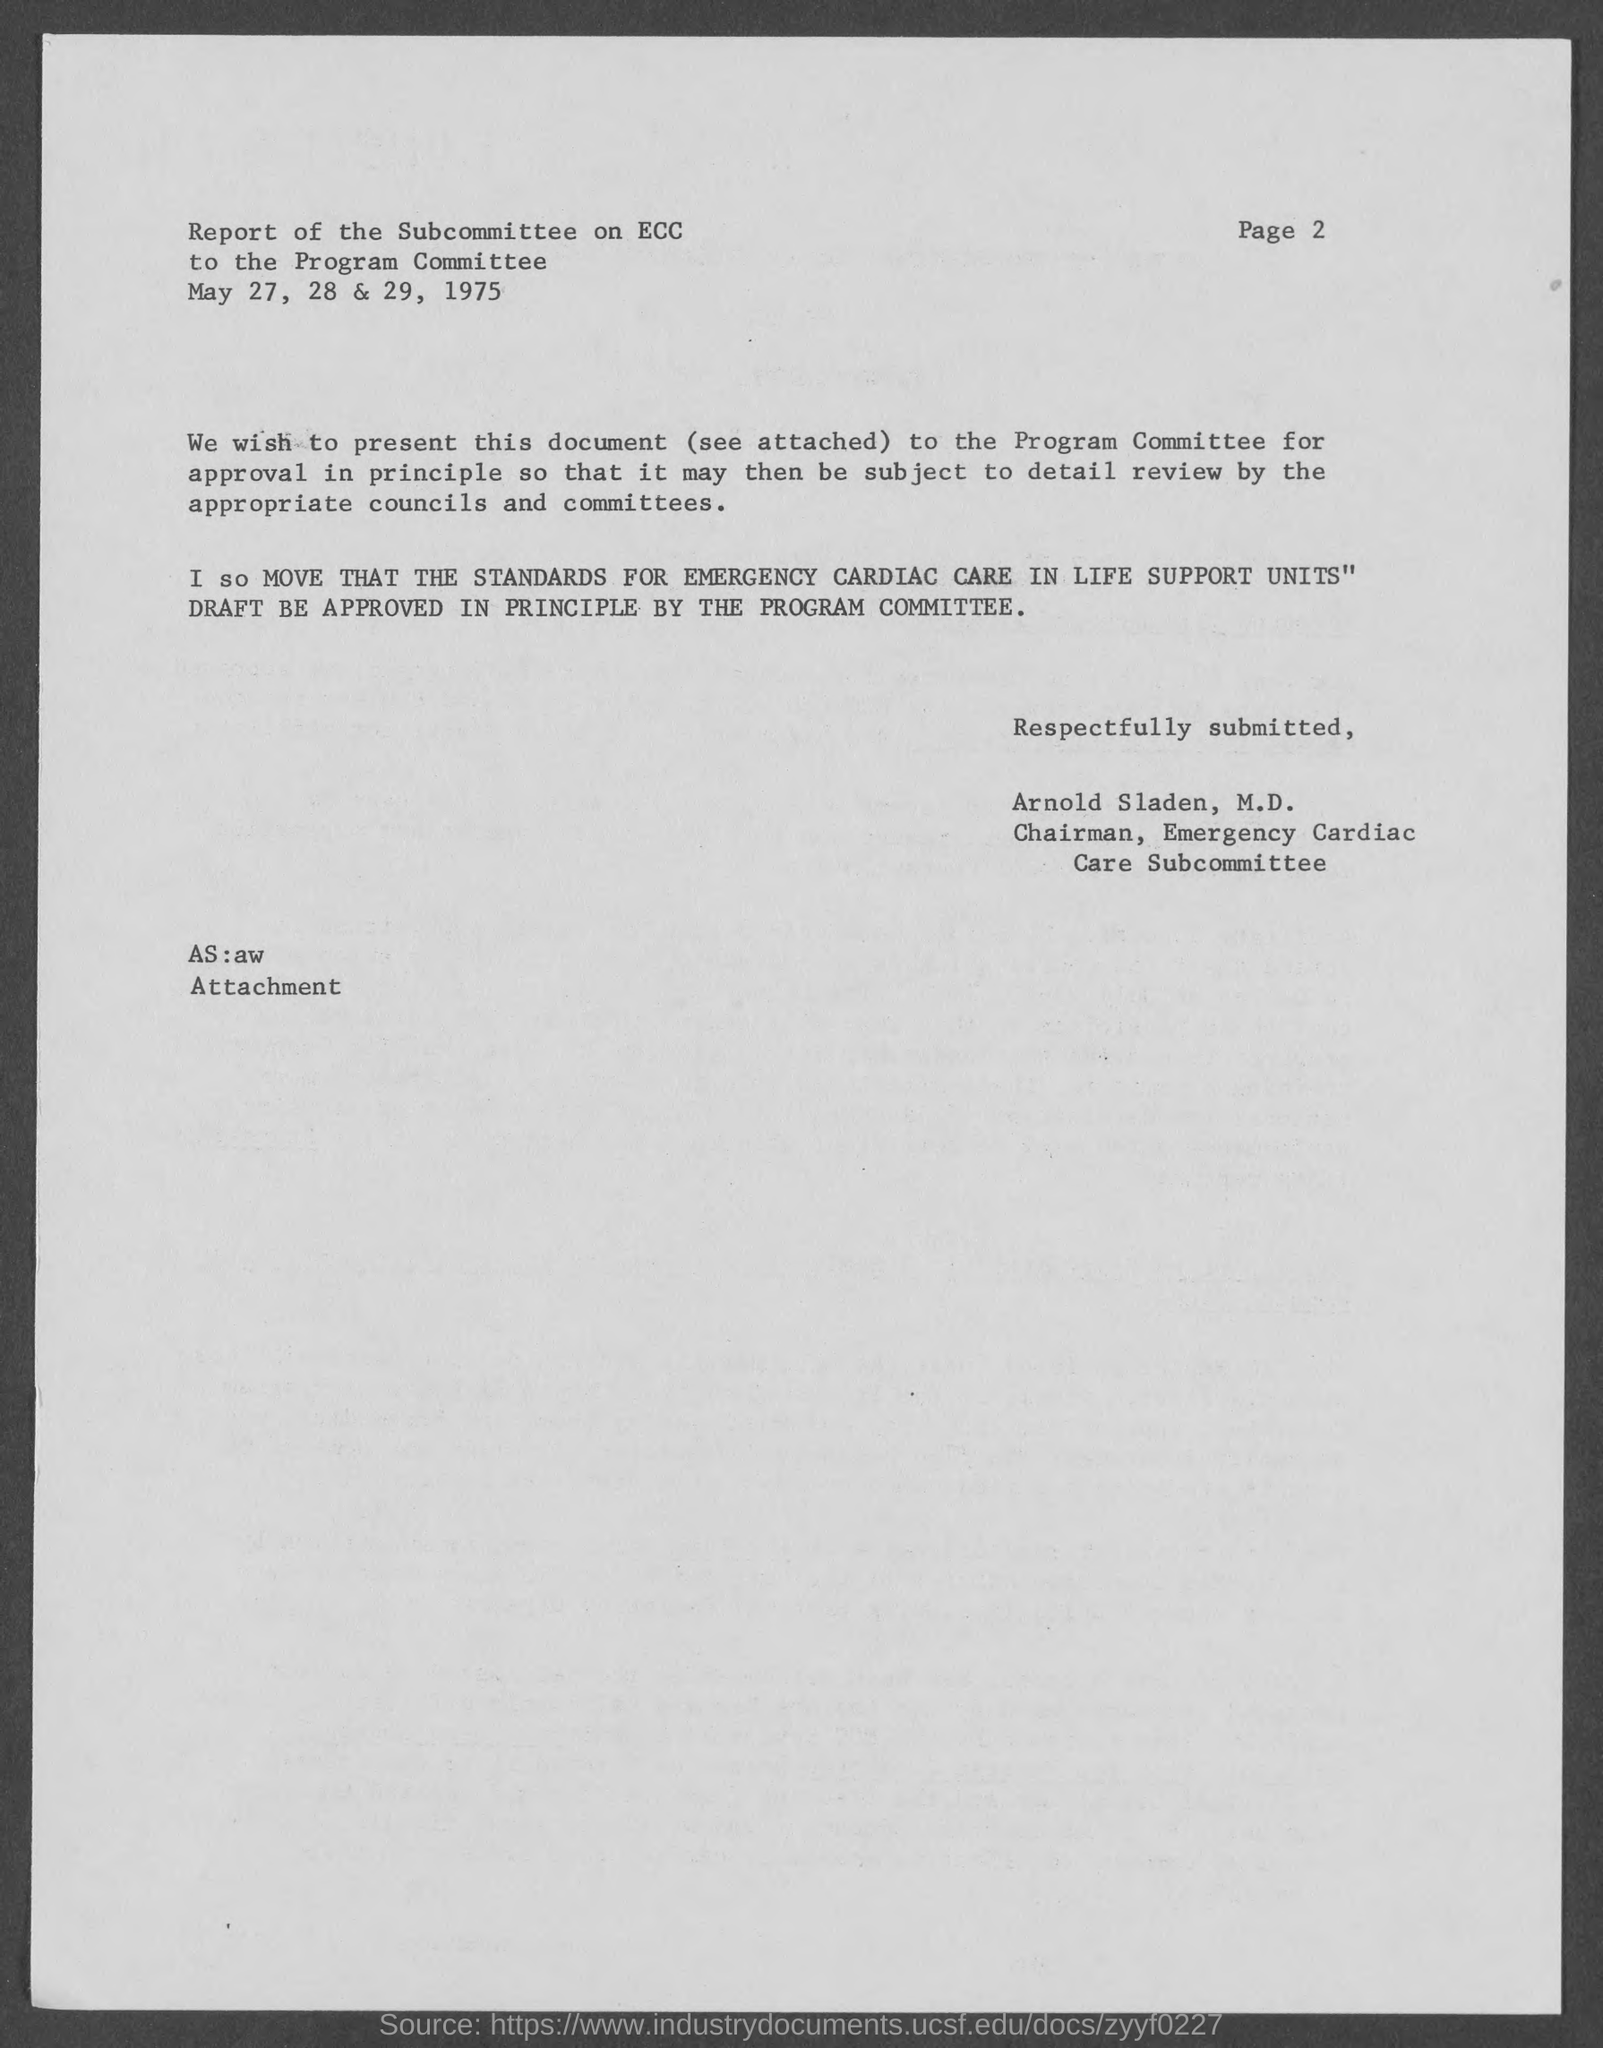What is the page number at top of the page?
Provide a succinct answer. 2. 